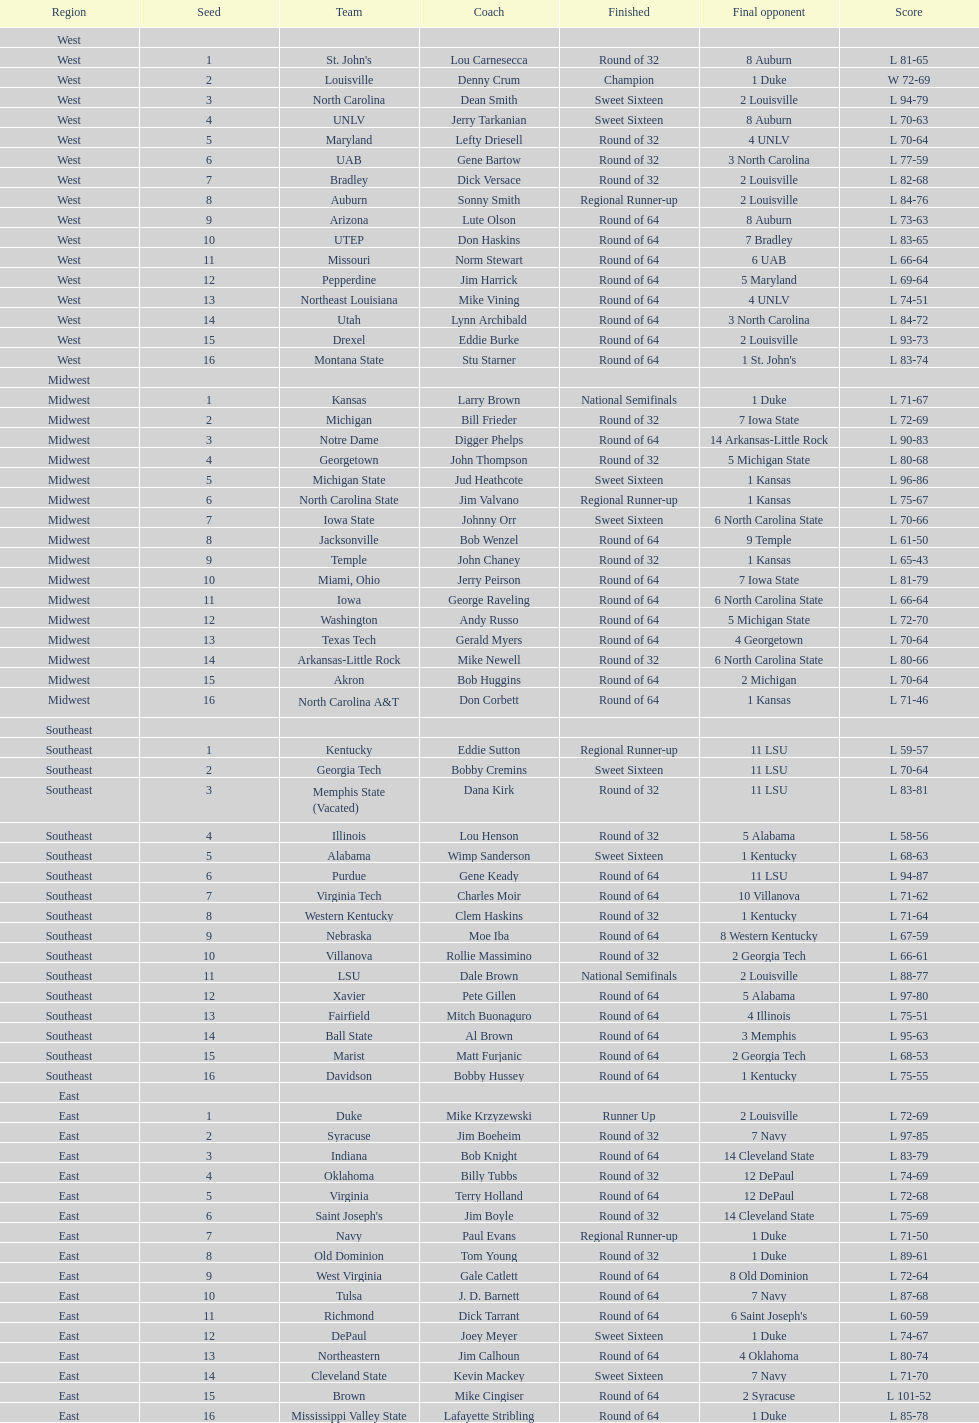How many teams are in the east region. 16. 